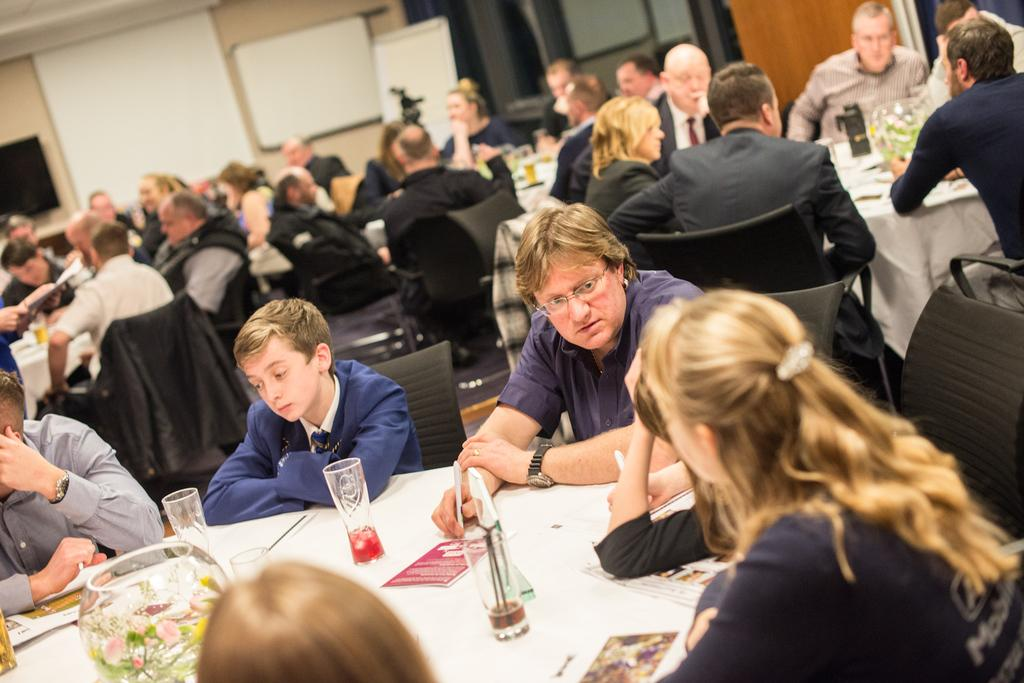How many people are in the image? There is a group of people in the image. What are the people doing in the image? The people are sitting on chairs. Where are the chairs located in relation to the tables? The chairs are in front of tables. What can be seen on the tables besides the chairs? There are glasses and other objects on the tables. What is visible on the wall in the background? There are boards on the wall in the background. What type of stone is being used to stretch the chairs in the image? There is no stone or stretching activity present in the image. Who is the representative of the group in the image? The image does not indicate the presence of a representative for the group. 